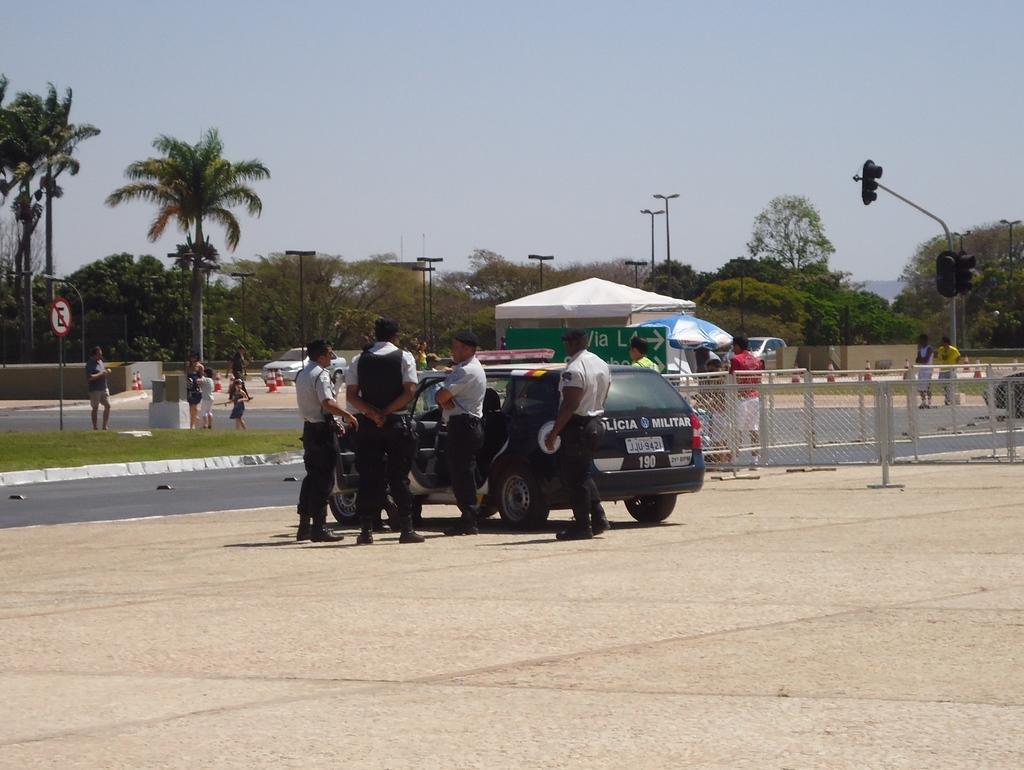Could you give a brief overview of what you see in this image? In this image I can see few people around. I can see few vehicles,trees,light poles,traffic signals,sign boards,tents,umbrellas and fencing. The sky is in blue and white color. 